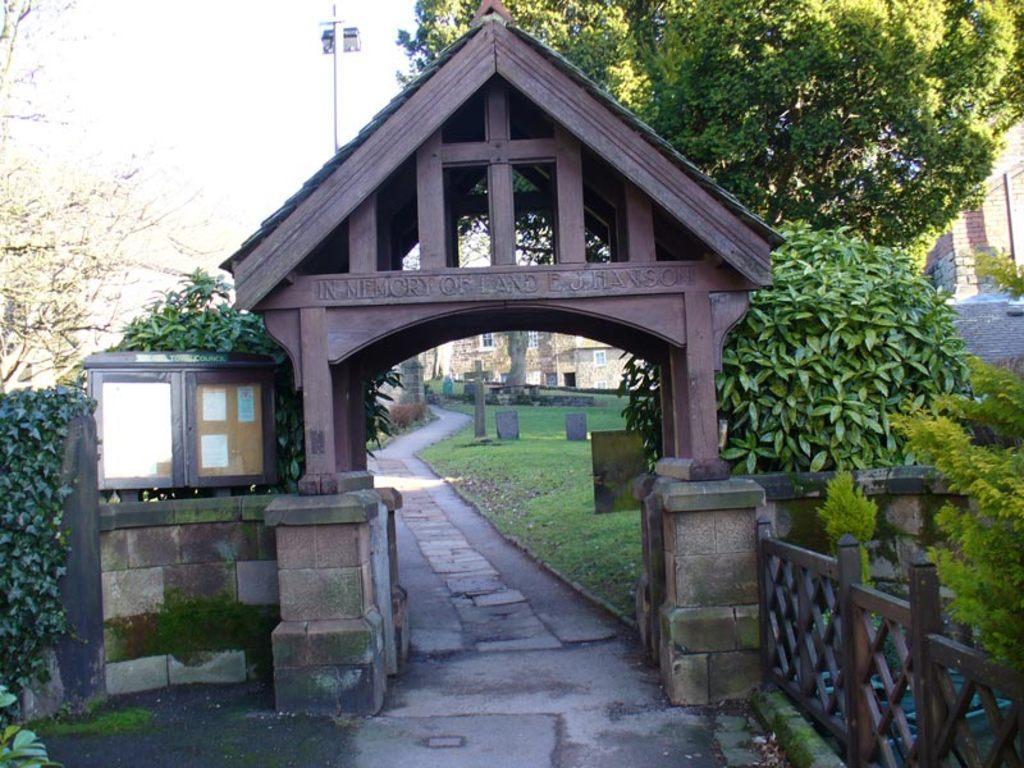Describe this image in one or two sentences. In this image we can see the entrance arch, wooden grills, creepers, plants, trees, grave stones, buildings and sky. 